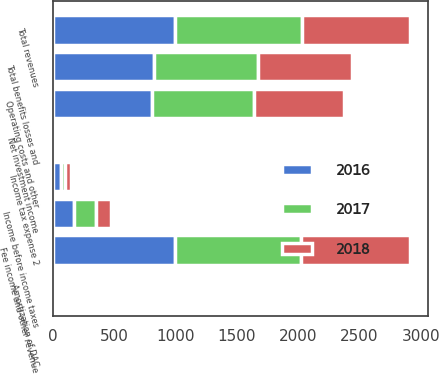Convert chart to OTSL. <chart><loc_0><loc_0><loc_500><loc_500><stacked_bar_chart><ecel><fcel>Fee income and other revenue<fcel>Net investment income<fcel>Total revenues<fcel>Amortization of DAC<fcel>Operating costs and other<fcel>Total benefits losses and<fcel>Income before income taxes<fcel>Income tax expense 2<nl><fcel>2017<fcel>1032<fcel>5<fcel>1033<fcel>16<fcel>831<fcel>847<fcel>186<fcel>38<nl><fcel>2016<fcel>992<fcel>3<fcel>995<fcel>21<fcel>805<fcel>826<fcel>169<fcel>63<nl><fcel>2018<fcel>885<fcel>1<fcel>886<fcel>24<fcel>741<fcel>765<fcel>121<fcel>43<nl></chart> 